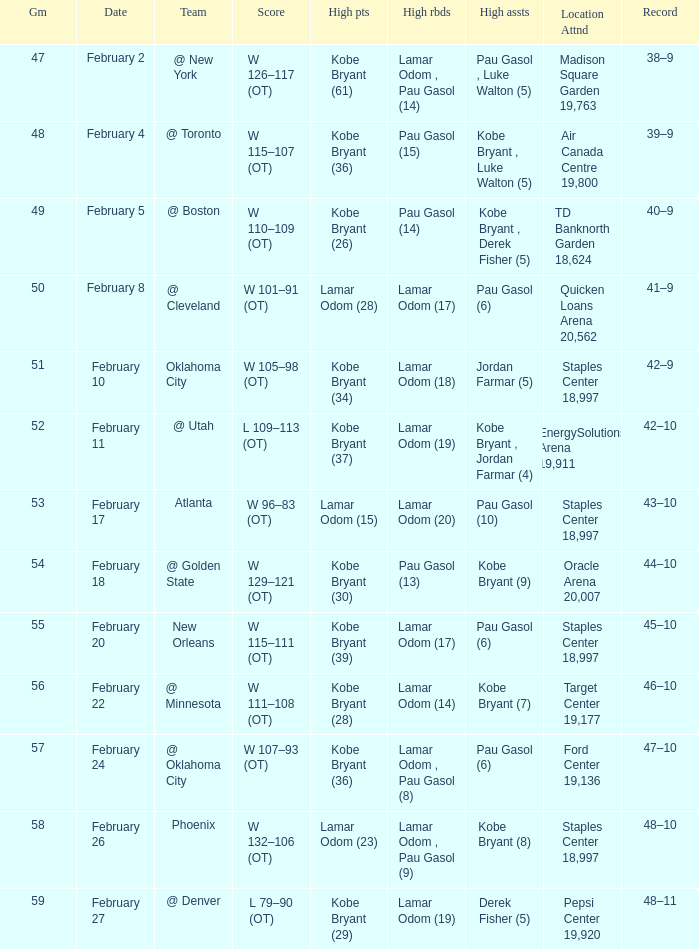Who had the most assists in the game against Atlanta? Pau Gasol (10). 